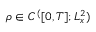Convert formula to latex. <formula><loc_0><loc_0><loc_500><loc_500>\rho \in C ^ { ( } [ 0 , T ] ; L _ { x } ^ { 2 } )</formula> 